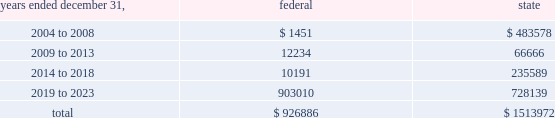American tower corporation and subsidiaries notes to consolidated financial statements 2014 ( continued ) basis step-up from corporate restructuring represents the tax effects of increasing the basis for tax purposes of certain of the company 2019s assets in conjunction with its spin-off from american radio systems corporation , its former parent company .
At december 31 , 2003 , the company had net federal and state operating loss carryforwards available to reduce future taxable income of approximately $ 0.9 billion and $ 1.5 billion , respectively .
If not utilized , the company 2019s net operating loss carryforwards expire as follows ( in thousands ) : .
Sfas no .
109 , 201caccounting for income taxes , 201d requires that companies record a valuation allowance when it is 201cmore likely than not that some portion or all of the deferred tax assets will not be realized . 201d at december 31 , 2003 , the company has provided a valuation allowance of approximately $ 156.7 million , primarily related to net state deferred tax assets , capital loss carryforwards and the lost tax benefit and costs associated with our tax refund claims .
The company has not provided a valuation allowance for the remaining net deferred tax assets , primarily its tax refund claims and federal net operating loss carryforwards , as management believes the company will be successful with its tax refund claims and have sufficient time to realize these federal net operating loss carryforwards during the twenty-year tax carryforward period .
The company intends to recover a portion of its deferred tax asset through its tax refund claims , related to certain federal net operating losses , filed during 2003 as part of a tax planning strategy implemented in 2002 .
The recoverability of its remaining net deferred tax asset has been assessed utilizing stable state ( no growth ) projections based on its current operations .
The projections show a significant decrease in depreciation and interest expense in the later years of the carryforward period as a result of a significant portion of its assets being fully depreciated during the first fifteen years of the carryforward period and debt repayments reducing interest expense .
Accordingly , the recoverability of the net deferred tax asset is not dependent on material improvements to operations , material asset sales or other non-routine transactions .
Based on its current outlook of future taxable income during the carryforward period , management believes that the net deferred tax asset will be realized .
The realization of the company 2019s deferred tax assets will be dependent upon its ability to generate approximately $ 1.0 billion in taxable income from january 1 , 2004 to december 31 , 2023 .
If the company is unable to generate sufficient taxable income in the future , or carry back losses as described above , it will be required to reduce its net deferred tax asset through a charge to income tax expense , which would result in a corresponding decrease in stockholders 2019 equity .
Depending on the resolution of the verestar bankruptcy proceedings described in note 2 , the company may be entitled to a worthless stock or bad debt deduction for its investment in verestar .
No income tax benefit has been provided for these potential deductions due to the uncertainty surrounding the bankruptcy proceedings .
13 .
Stockholders 2019 equity preferred stock as of december 31 , 2003 the company was authorized to issue up to 20.0 million shares of $ .01 par value preferred stock .
As of december 31 , 2003 and 2002 there were no preferred shares issued or outstanding. .
What portion of the state operating loss carryforwards expires between 2004 and 2008? 
Computations: (483578 / 1513972)
Answer: 0.31941. 